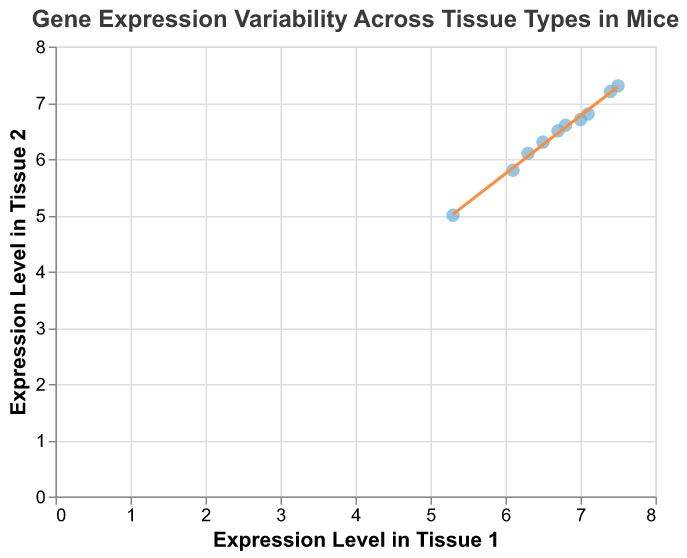How many data points are plotted in the figure? Count the number of points plotted. There are 10 genes listed, so there should be 10 data points.
Answer: 10 What are the axis titles in the figure? Observe the labels on the horizontal and vertical axes. The horizontal axis is labeled "Expression Level in Tissue 1", and the vertical axis is labeled "Expression Level in Tissue 2".
Answer: "Expression Level in Tissue 1" and "Expression Level in Tissue 2" What is the range of expression levels for Tissue 1? Look at the minimum and maximum values on the horizontal axis. The smallest value is 5.3, and the largest value is 7.5.
Answer: 5.3 - 7.5 Which gene shows the highest expression level in Tissue 2? Hover over the data points to see the tooltips. The gene Ppia shows the highest expression level, with a value of 7.3.
Answer: Ppia How does the trend line behave in the plot? Observe the orientation of the trend line. The line shows a positive trend, indicating that as the expression level in Tissue 1 increases, the expression level in Tissue 2 also increases.
Answer: Positive trend Identify the gene with the largest difference in expression levels between the two tissues. Compare the expression levels for each gene. The largest difference is for the gene Pgk1, with Tissue 1 having an expression level of 6.1 and Tissue 2 having an expression level of 5.8. The difference is 0.3.
Answer: Pgk1 What's the average expression level in Tissue 1 for all genes? Sum the expression levels in Tissue 1 (7.1 + 6.5 + 5.3 + 6.8 + 7.4 + 6.1 + 7.0 + 6.7 + 6.3 + 7.5) and divide by the number of genes (10). The sum is 66.7, so the average is 66.7 / 10 = 6.67
Answer: 6.67 Which gene has equal or almost equal expression levels in both tissues? Check the tooltips for each point to find genes with similar values in Tissue 1 and Tissue 2. The gene B2m shows very similar values with 7.4 in Tissue 1 and 7.2 in Tissue 2.
Answer: B2m Does any data point seem like an outlier compared to the trend line? Observe the scatter plot and the trend line. Compare the position of data points relative to the trend line. All points seem to fit closely to the line, with no significant outliers.
Answer: No What does the slope of the trend line suggest about gene expression? A positive slope indicates a direct relationship between the expression levels in Tissue 1 and Tissue 2. This means genes expressed higher in Tissue 1 also tend to be expressed higher in Tissue 2.
Answer: Direct relationship 